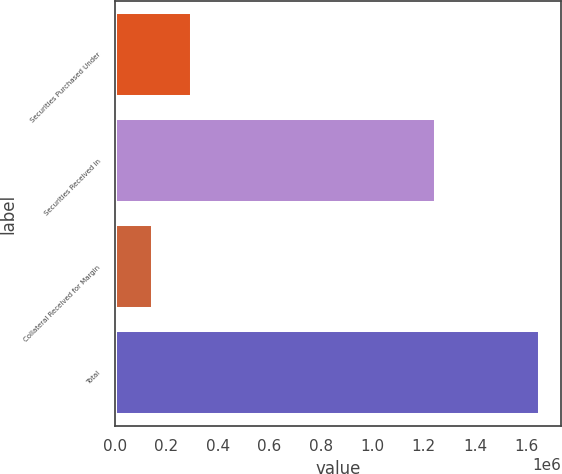<chart> <loc_0><loc_0><loc_500><loc_500><bar_chart><fcel>Securities Purchased Under<fcel>Securities Received in<fcel>Collateral Received for Margin<fcel>Total<nl><fcel>298826<fcel>1.24878e+06<fcel>148596<fcel>1.65089e+06<nl></chart> 